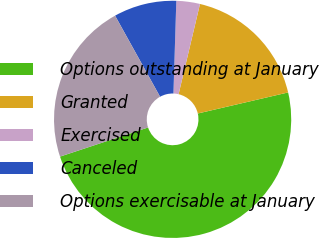Convert chart. <chart><loc_0><loc_0><loc_500><loc_500><pie_chart><fcel>Options outstanding at January<fcel>Granted<fcel>Exercised<fcel>Canceled<fcel>Options exercisable at January<nl><fcel>48.56%<fcel>17.65%<fcel>3.21%<fcel>8.56%<fcel>22.02%<nl></chart> 